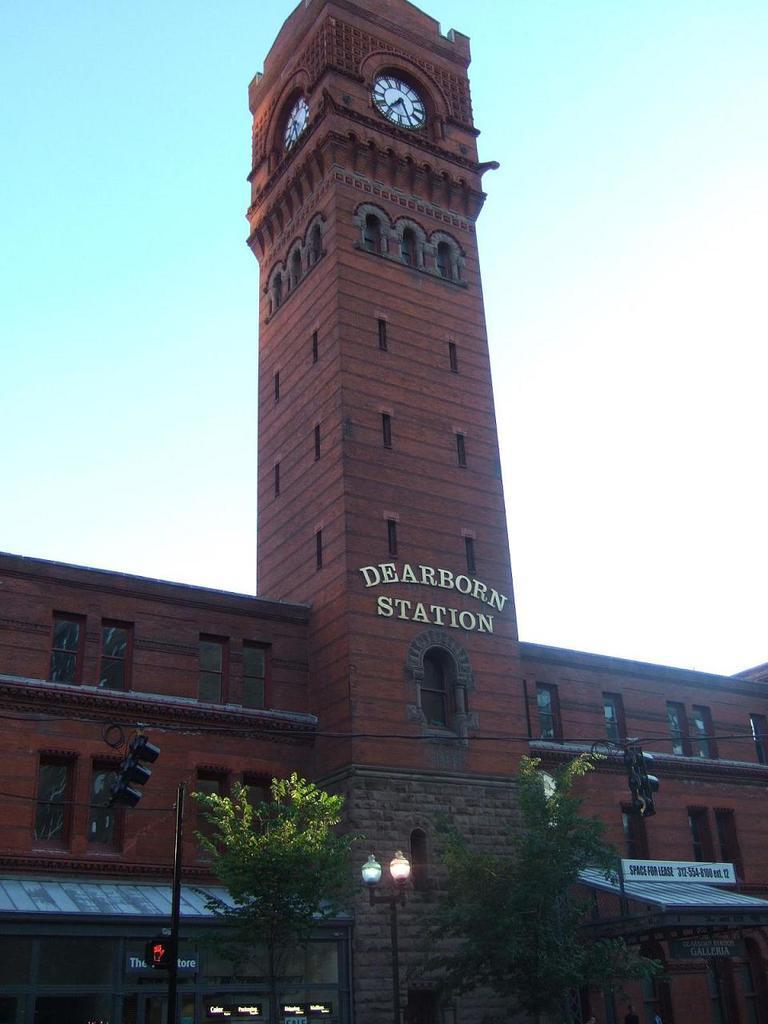Describe this image in one or two sentences. In this picture there is a building, there is a text and there are clocks on the wall. In the foreground there are trees and poles. At the top there is sky. 